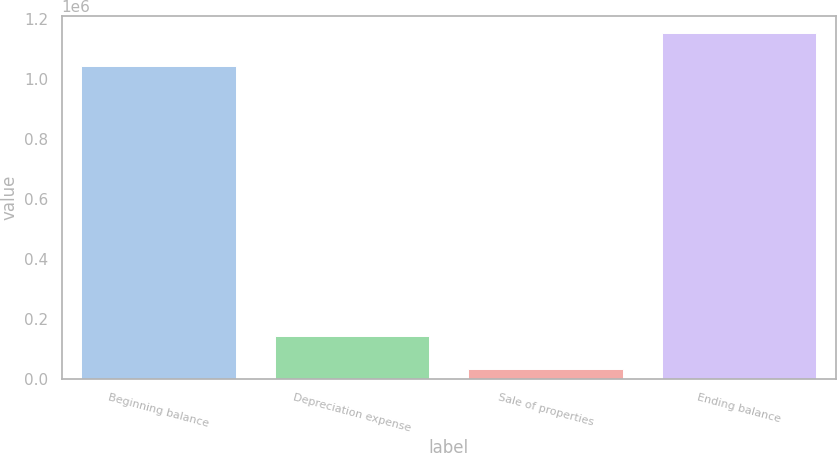Convert chart to OTSL. <chart><loc_0><loc_0><loc_500><loc_500><bar_chart><fcel>Beginning balance<fcel>Depreciation expense<fcel>Sale of properties<fcel>Ending balance<nl><fcel>1.04379e+06<fcel>141951<fcel>32791<fcel>1.15295e+06<nl></chart> 